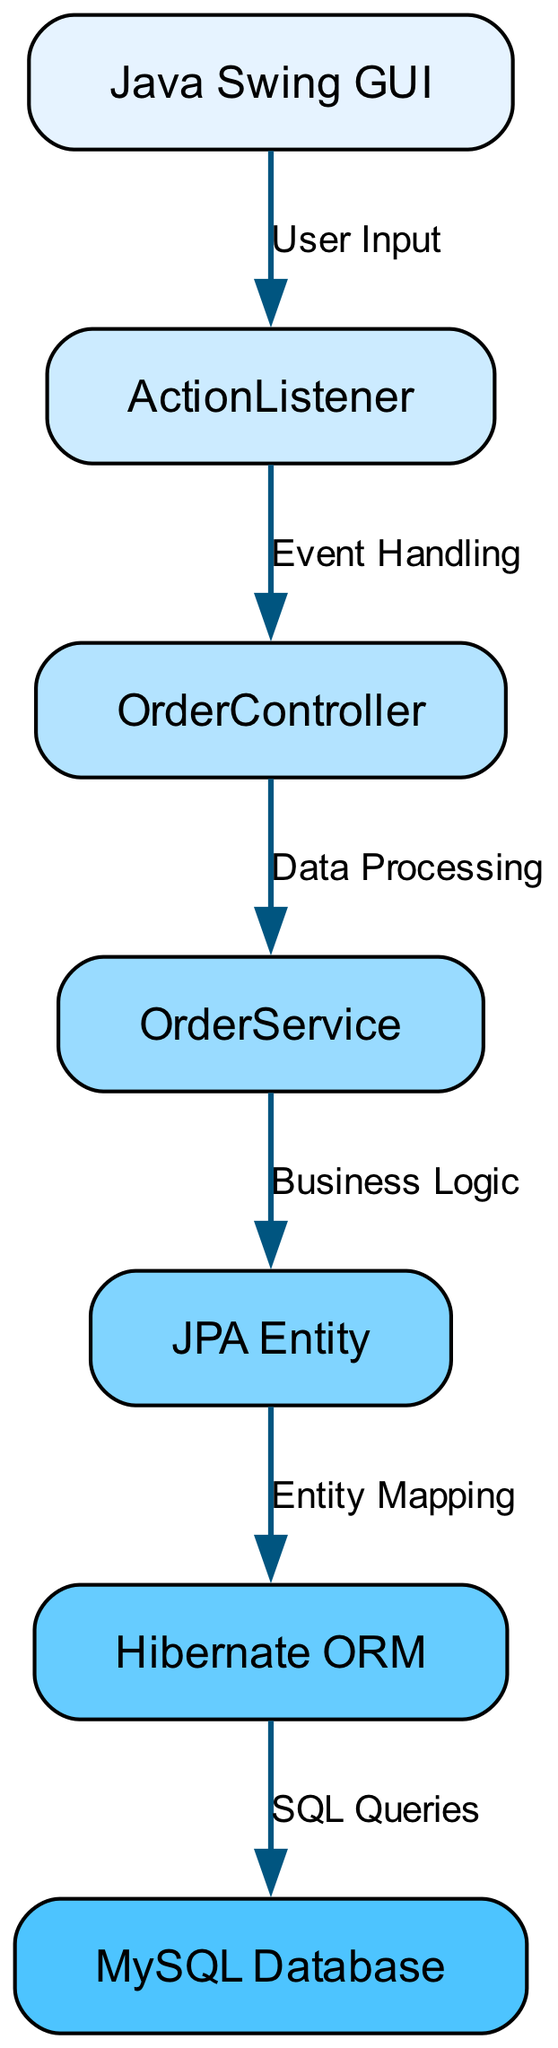What is the starting node in the data flow? The diagram starts with the "Java Swing GUI" node, which represents the user interface where input is initially gathered.
Answer: Java Swing GUI How many nodes are present in the diagram? By counting the nodes listed, we find there are a total of six nodes: Java Swing GUI, ActionListener, OrderController, OrderService, JPA Entity, Hibernate ORM, and MySQL Database.
Answer: 6 What type of relationship connects the Java Swing GUI to ActionListener? The relationship between these nodes is indicated by "User Input," which signifies that user interactions are handled by the ActionListener.
Answer: User Input Which node is responsible for business logic? The "OrderService" node is responsible for implementing the business logic related to processing orders within the system.
Answer: OrderService What is the final destination for data storage in the diagram? The MySQL Database node is the final destination for data storage, as indicated by the flow from Hibernate ORM to this node for persisting data.
Answer: MySQL Database What edge describes the action of transforming JPA entities to database records? The edge "SQL Queries" describes the action of translating JPA entities into SQL commands to be executed on the database for data manipulation.
Answer: SQL Queries How many edges are in the diagram? The edges connecting the nodes consist of seven relationships that detail the flow of data through the system, indicating that there are seven edges in total.
Answer: 7 What is the penultimate node before data storage? The node before data storage is "Hibernate ORM," which interfaces with the database to handle entity management and querying.
Answer: Hibernate ORM What is represented as the intermediary between user actions and order processing? The actions triggered by user input are handled by the "ActionListener," which serves as the intermediary, receiving events from the GUI.
Answer: ActionListener 